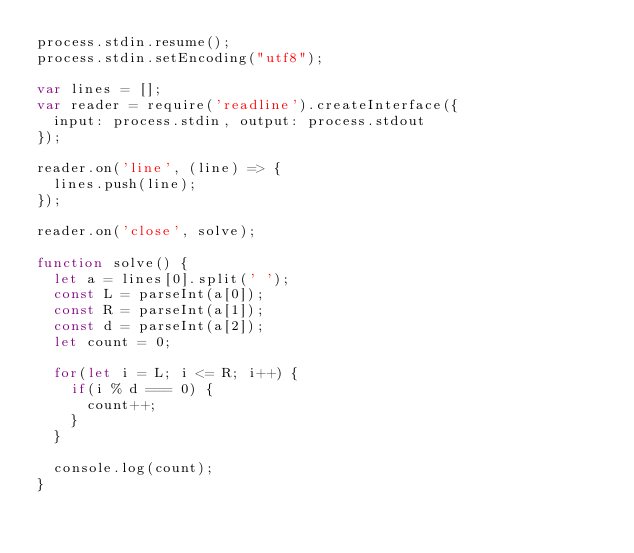Convert code to text. <code><loc_0><loc_0><loc_500><loc_500><_JavaScript_>process.stdin.resume();
process.stdin.setEncoding("utf8");

var lines = [];
var reader = require('readline').createInterface({
  input: process.stdin, output: process.stdout
});

reader.on('line', (line) => {
  lines.push(line);
});

reader.on('close', solve);

function solve() {
  let a = lines[0].split(' ');
  const L = parseInt(a[0]);
  const R = parseInt(a[1]);
  const d = parseInt(a[2]);
  let count = 0;

  for(let i = L; i <= R; i++) {
    if(i % d === 0) {
      count++;
    }
  }

  console.log(count);
}</code> 